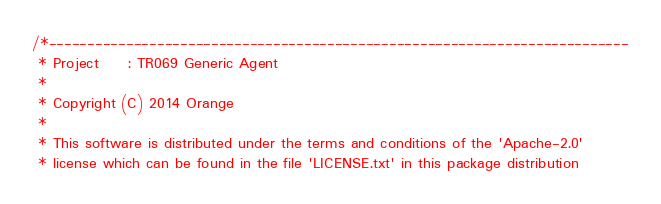<code> <loc_0><loc_0><loc_500><loc_500><_C_>/*---------------------------------------------------------------------------
 * Project     : TR069 Generic Agent
 *
 * Copyright (C) 2014 Orange
 *
 * This software is distributed under the terms and conditions of the 'Apache-2.0'
 * license which can be found in the file 'LICENSE.txt' in this package distribution</code> 